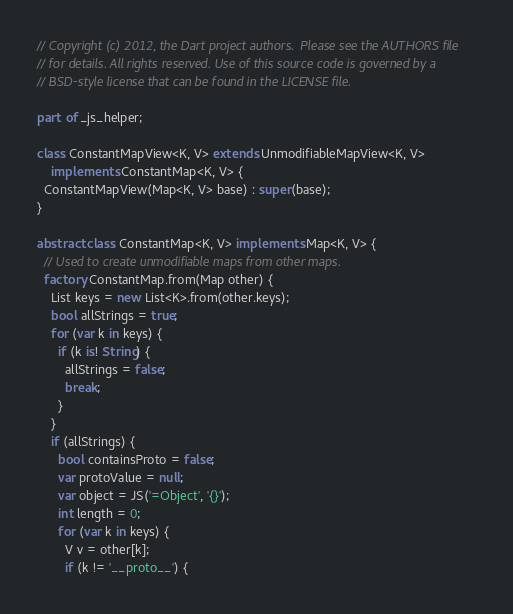Convert code to text. <code><loc_0><loc_0><loc_500><loc_500><_Dart_>// Copyright (c) 2012, the Dart project authors.  Please see the AUTHORS file
// for details. All rights reserved. Use of this source code is governed by a
// BSD-style license that can be found in the LICENSE file.

part of _js_helper;

class ConstantMapView<K, V> extends UnmodifiableMapView<K, V>
    implements ConstantMap<K, V> {
  ConstantMapView(Map<K, V> base) : super(base);
}

abstract class ConstantMap<K, V> implements Map<K, V> {
  // Used to create unmodifiable maps from other maps.
  factory ConstantMap.from(Map other) {
    List keys = new List<K>.from(other.keys);
    bool allStrings = true;
    for (var k in keys) {
      if (k is! String) {
        allStrings = false;
        break;
      }
    }
    if (allStrings) {
      bool containsProto = false;
      var protoValue = null;
      var object = JS('=Object', '{}');
      int length = 0;
      for (var k in keys) {
        V v = other[k];
        if (k != '__proto__') {</code> 